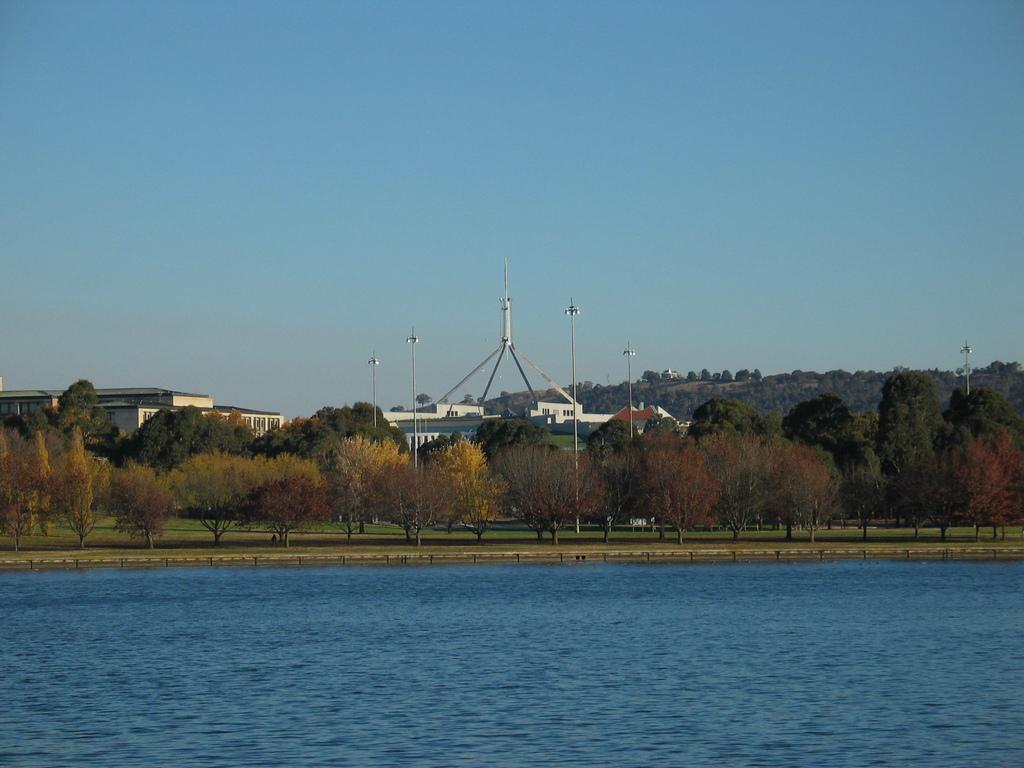How would you summarize this image in a sentence or two? In this image we can see some trees, buildings, poles and other objects. At the top of the image there is the sky. At the bottom of the image there is water. 